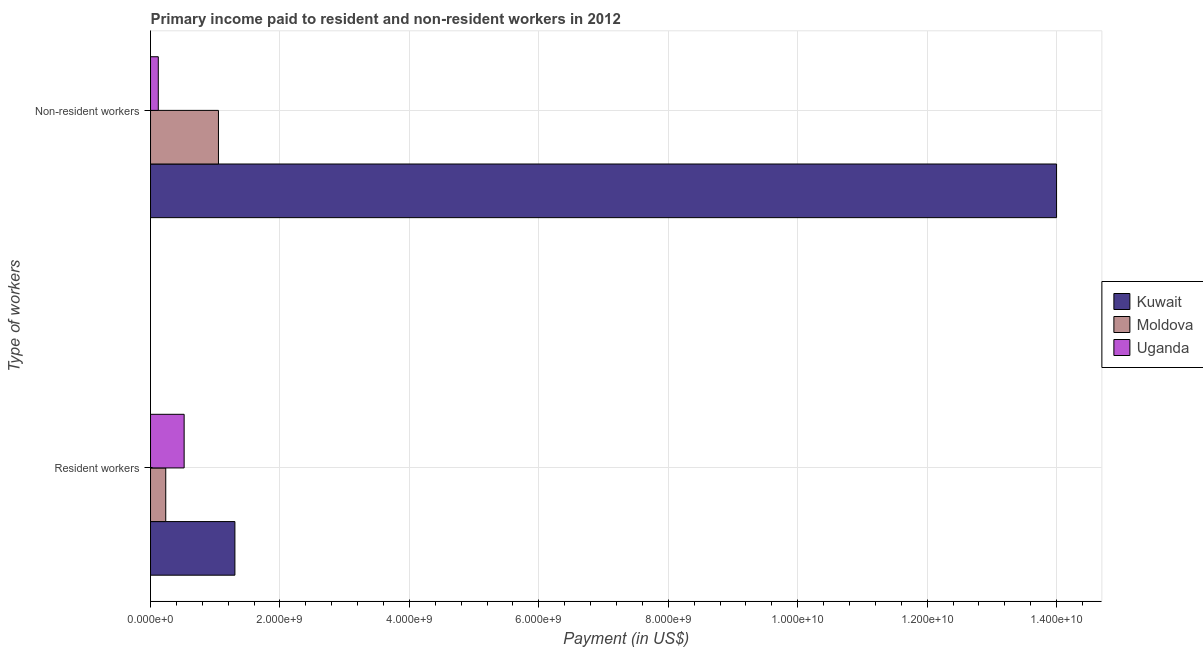How many bars are there on the 2nd tick from the bottom?
Ensure brevity in your answer.  3. What is the label of the 1st group of bars from the top?
Offer a very short reply. Non-resident workers. What is the payment made to resident workers in Moldova?
Your response must be concise. 2.35e+08. Across all countries, what is the maximum payment made to non-resident workers?
Offer a very short reply. 1.40e+1. Across all countries, what is the minimum payment made to non-resident workers?
Ensure brevity in your answer.  1.20e+08. In which country was the payment made to non-resident workers maximum?
Make the answer very short. Kuwait. In which country was the payment made to resident workers minimum?
Offer a very short reply. Moldova. What is the total payment made to non-resident workers in the graph?
Your response must be concise. 1.52e+1. What is the difference between the payment made to non-resident workers in Moldova and that in Kuwait?
Give a very brief answer. -1.29e+1. What is the difference between the payment made to non-resident workers in Uganda and the payment made to resident workers in Kuwait?
Make the answer very short. -1.18e+09. What is the average payment made to resident workers per country?
Provide a short and direct response. 6.86e+08. What is the difference between the payment made to non-resident workers and payment made to resident workers in Uganda?
Give a very brief answer. -3.99e+08. In how many countries, is the payment made to resident workers greater than 7200000000 US$?
Your answer should be compact. 0. What is the ratio of the payment made to non-resident workers in Uganda to that in Moldova?
Your answer should be very brief. 0.11. Is the payment made to resident workers in Moldova less than that in Kuwait?
Your response must be concise. Yes. In how many countries, is the payment made to resident workers greater than the average payment made to resident workers taken over all countries?
Provide a succinct answer. 1. What does the 2nd bar from the top in Non-resident workers represents?
Keep it short and to the point. Moldova. What does the 2nd bar from the bottom in Resident workers represents?
Your response must be concise. Moldova. What is the difference between two consecutive major ticks on the X-axis?
Give a very brief answer. 2.00e+09. Does the graph contain any zero values?
Offer a very short reply. No. Does the graph contain grids?
Keep it short and to the point. Yes. What is the title of the graph?
Keep it short and to the point. Primary income paid to resident and non-resident workers in 2012. What is the label or title of the X-axis?
Your answer should be compact. Payment (in US$). What is the label or title of the Y-axis?
Provide a short and direct response. Type of workers. What is the Payment (in US$) in Kuwait in Resident workers?
Offer a terse response. 1.30e+09. What is the Payment (in US$) in Moldova in Resident workers?
Your answer should be compact. 2.35e+08. What is the Payment (in US$) of Uganda in Resident workers?
Provide a short and direct response. 5.19e+08. What is the Payment (in US$) in Kuwait in Non-resident workers?
Make the answer very short. 1.40e+1. What is the Payment (in US$) of Moldova in Non-resident workers?
Provide a succinct answer. 1.05e+09. What is the Payment (in US$) of Uganda in Non-resident workers?
Ensure brevity in your answer.  1.20e+08. Across all Type of workers, what is the maximum Payment (in US$) of Kuwait?
Provide a succinct answer. 1.40e+1. Across all Type of workers, what is the maximum Payment (in US$) of Moldova?
Give a very brief answer. 1.05e+09. Across all Type of workers, what is the maximum Payment (in US$) in Uganda?
Give a very brief answer. 5.19e+08. Across all Type of workers, what is the minimum Payment (in US$) of Kuwait?
Offer a very short reply. 1.30e+09. Across all Type of workers, what is the minimum Payment (in US$) in Moldova?
Ensure brevity in your answer.  2.35e+08. Across all Type of workers, what is the minimum Payment (in US$) in Uganda?
Ensure brevity in your answer.  1.20e+08. What is the total Payment (in US$) of Kuwait in the graph?
Offer a terse response. 1.53e+1. What is the total Payment (in US$) of Moldova in the graph?
Provide a succinct answer. 1.28e+09. What is the total Payment (in US$) in Uganda in the graph?
Give a very brief answer. 6.39e+08. What is the difference between the Payment (in US$) in Kuwait in Resident workers and that in Non-resident workers?
Your answer should be compact. -1.27e+1. What is the difference between the Payment (in US$) in Moldova in Resident workers and that in Non-resident workers?
Provide a short and direct response. -8.14e+08. What is the difference between the Payment (in US$) in Uganda in Resident workers and that in Non-resident workers?
Offer a terse response. 3.99e+08. What is the difference between the Payment (in US$) of Kuwait in Resident workers and the Payment (in US$) of Moldova in Non-resident workers?
Your response must be concise. 2.54e+08. What is the difference between the Payment (in US$) of Kuwait in Resident workers and the Payment (in US$) of Uganda in Non-resident workers?
Your answer should be compact. 1.18e+09. What is the difference between the Payment (in US$) of Moldova in Resident workers and the Payment (in US$) of Uganda in Non-resident workers?
Offer a very short reply. 1.15e+08. What is the average Payment (in US$) of Kuwait per Type of workers?
Your response must be concise. 7.65e+09. What is the average Payment (in US$) in Moldova per Type of workers?
Your response must be concise. 6.42e+08. What is the average Payment (in US$) of Uganda per Type of workers?
Your answer should be very brief. 3.20e+08. What is the difference between the Payment (in US$) of Kuwait and Payment (in US$) of Moldova in Resident workers?
Ensure brevity in your answer.  1.07e+09. What is the difference between the Payment (in US$) in Kuwait and Payment (in US$) in Uganda in Resident workers?
Offer a terse response. 7.84e+08. What is the difference between the Payment (in US$) of Moldova and Payment (in US$) of Uganda in Resident workers?
Provide a short and direct response. -2.84e+08. What is the difference between the Payment (in US$) of Kuwait and Payment (in US$) of Moldova in Non-resident workers?
Provide a short and direct response. 1.29e+1. What is the difference between the Payment (in US$) of Kuwait and Payment (in US$) of Uganda in Non-resident workers?
Your answer should be compact. 1.39e+1. What is the difference between the Payment (in US$) of Moldova and Payment (in US$) of Uganda in Non-resident workers?
Keep it short and to the point. 9.29e+08. What is the ratio of the Payment (in US$) of Kuwait in Resident workers to that in Non-resident workers?
Offer a very short reply. 0.09. What is the ratio of the Payment (in US$) of Moldova in Resident workers to that in Non-resident workers?
Your answer should be compact. 0.22. What is the ratio of the Payment (in US$) of Uganda in Resident workers to that in Non-resident workers?
Provide a short and direct response. 4.32. What is the difference between the highest and the second highest Payment (in US$) of Kuwait?
Make the answer very short. 1.27e+1. What is the difference between the highest and the second highest Payment (in US$) of Moldova?
Make the answer very short. 8.14e+08. What is the difference between the highest and the second highest Payment (in US$) of Uganda?
Give a very brief answer. 3.99e+08. What is the difference between the highest and the lowest Payment (in US$) in Kuwait?
Give a very brief answer. 1.27e+1. What is the difference between the highest and the lowest Payment (in US$) of Moldova?
Offer a very short reply. 8.14e+08. What is the difference between the highest and the lowest Payment (in US$) in Uganda?
Your answer should be compact. 3.99e+08. 